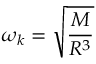Convert formula to latex. <formula><loc_0><loc_0><loc_500><loc_500>\omega _ { k } = \sqrt { \frac { M } { R ^ { 3 } } }</formula> 